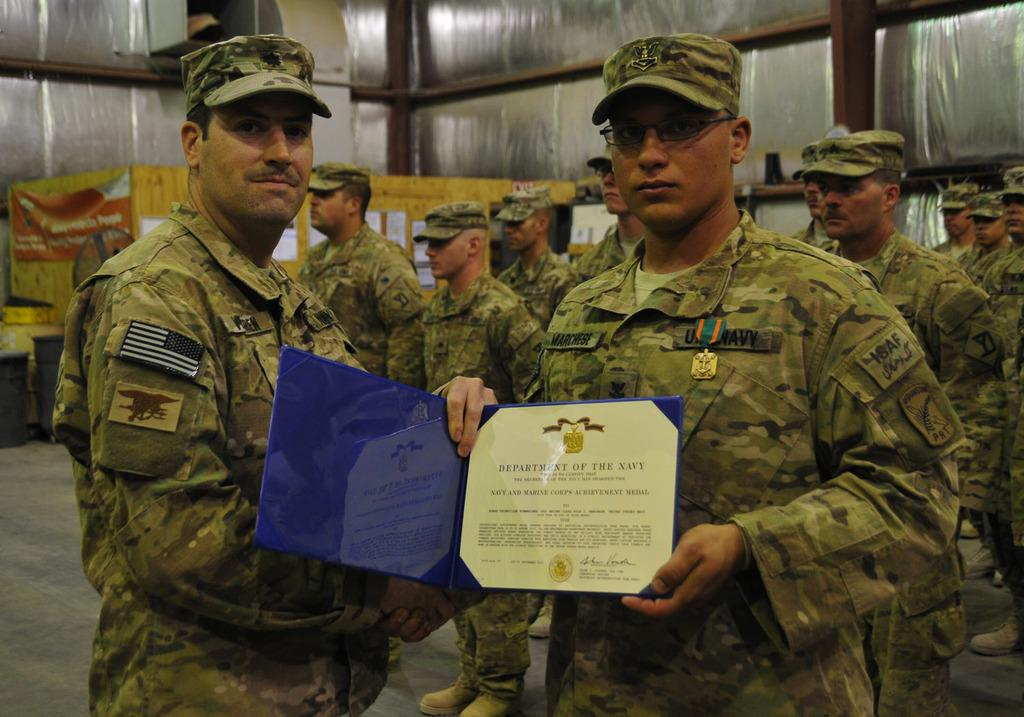What is the main subject of the image? The main subject of the image is people. What are the people wearing in the image? The people are wearing uniforms and caps in the image. What are the people doing in the image? The people are standing in the image. What can be seen in the background of the image? There are containers in the background of the image. What type of pear can be seen on the ground in the image? There is no pear present in the image; it features people wearing uniforms and caps, standing in front of containers. How much dust is visible on the people's uniforms in the image? There is no indication of dust on the people's uniforms in the image. 